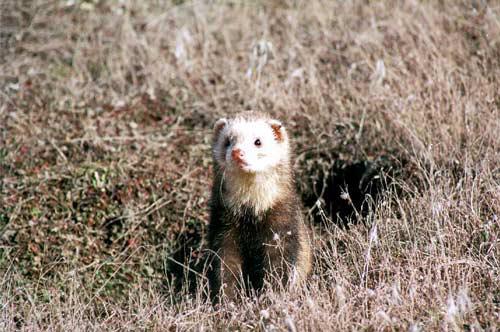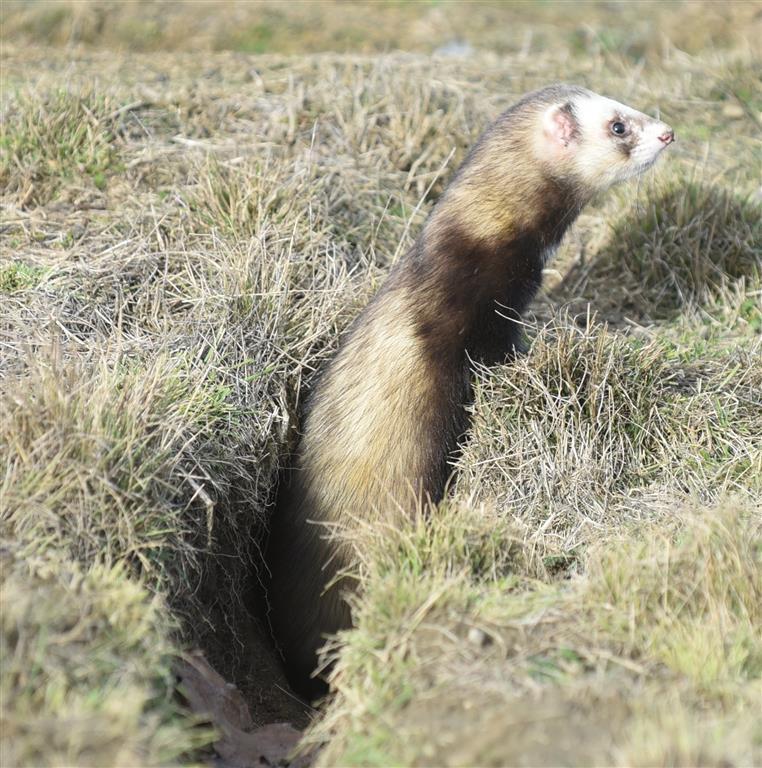The first image is the image on the left, the second image is the image on the right. Considering the images on both sides, is "An image shows a row of exactly three ferret-like animals of different sizes." valid? Answer yes or no. No. The first image is the image on the left, the second image is the image on the right. Considering the images on both sides, is "Three animals are stretched out of the leaves in one of the images." valid? Answer yes or no. No. 